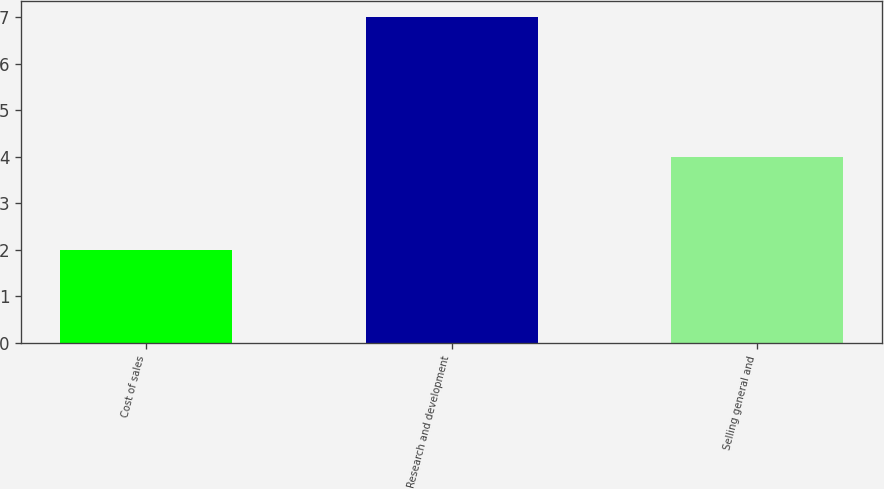<chart> <loc_0><loc_0><loc_500><loc_500><bar_chart><fcel>Cost of sales<fcel>Research and development<fcel>Selling general and<nl><fcel>2<fcel>7<fcel>4<nl></chart> 